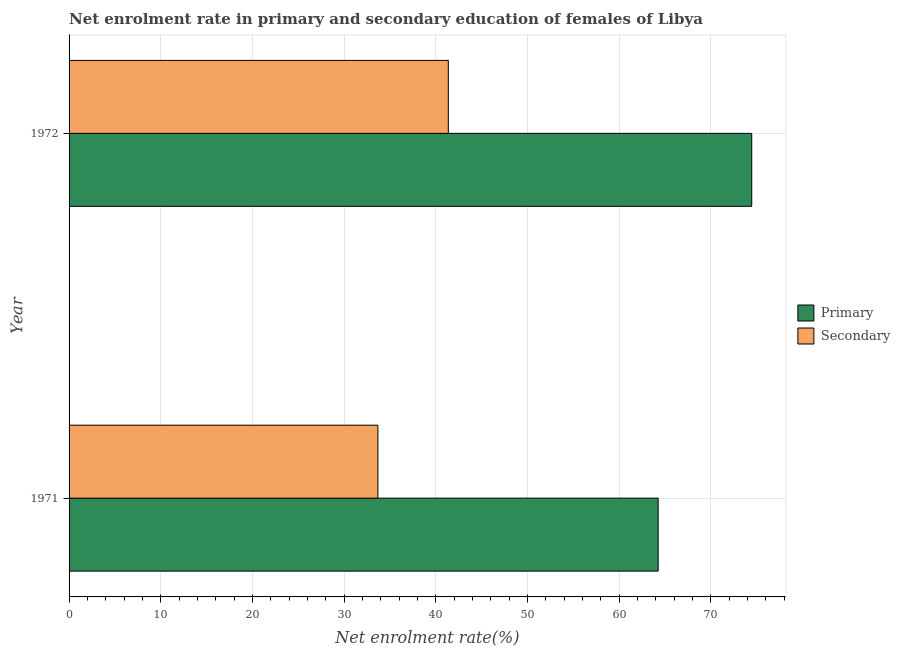How many different coloured bars are there?
Ensure brevity in your answer.  2. How many groups of bars are there?
Make the answer very short. 2. What is the enrollment rate in primary education in 1972?
Make the answer very short. 74.48. Across all years, what is the maximum enrollment rate in primary education?
Offer a terse response. 74.48. Across all years, what is the minimum enrollment rate in primary education?
Offer a very short reply. 64.27. In which year was the enrollment rate in primary education minimum?
Give a very brief answer. 1971. What is the total enrollment rate in secondary education in the graph?
Provide a succinct answer. 75.07. What is the difference between the enrollment rate in secondary education in 1971 and that in 1972?
Offer a terse response. -7.68. What is the difference between the enrollment rate in secondary education in 1971 and the enrollment rate in primary education in 1972?
Provide a short and direct response. -40.79. What is the average enrollment rate in secondary education per year?
Ensure brevity in your answer.  37.53. In the year 1971, what is the difference between the enrollment rate in secondary education and enrollment rate in primary education?
Your answer should be very brief. -30.58. What is the ratio of the enrollment rate in primary education in 1971 to that in 1972?
Provide a succinct answer. 0.86. Is the enrollment rate in primary education in 1971 less than that in 1972?
Your answer should be compact. Yes. In how many years, is the enrollment rate in primary education greater than the average enrollment rate in primary education taken over all years?
Provide a succinct answer. 1. What does the 2nd bar from the top in 1972 represents?
Make the answer very short. Primary. What does the 1st bar from the bottom in 1971 represents?
Keep it short and to the point. Primary. How many bars are there?
Offer a very short reply. 4. Are all the bars in the graph horizontal?
Provide a succinct answer. Yes. How many years are there in the graph?
Keep it short and to the point. 2. Are the values on the major ticks of X-axis written in scientific E-notation?
Ensure brevity in your answer.  No. How are the legend labels stacked?
Your answer should be compact. Vertical. What is the title of the graph?
Your response must be concise. Net enrolment rate in primary and secondary education of females of Libya. What is the label or title of the X-axis?
Provide a short and direct response. Net enrolment rate(%). What is the Net enrolment rate(%) in Primary in 1971?
Provide a short and direct response. 64.27. What is the Net enrolment rate(%) in Secondary in 1971?
Offer a terse response. 33.69. What is the Net enrolment rate(%) in Primary in 1972?
Offer a very short reply. 74.48. What is the Net enrolment rate(%) of Secondary in 1972?
Ensure brevity in your answer.  41.38. Across all years, what is the maximum Net enrolment rate(%) in Primary?
Provide a short and direct response. 74.48. Across all years, what is the maximum Net enrolment rate(%) in Secondary?
Provide a short and direct response. 41.38. Across all years, what is the minimum Net enrolment rate(%) in Primary?
Offer a very short reply. 64.27. Across all years, what is the minimum Net enrolment rate(%) of Secondary?
Your answer should be very brief. 33.69. What is the total Net enrolment rate(%) in Primary in the graph?
Provide a succinct answer. 138.75. What is the total Net enrolment rate(%) in Secondary in the graph?
Make the answer very short. 75.07. What is the difference between the Net enrolment rate(%) of Primary in 1971 and that in 1972?
Ensure brevity in your answer.  -10.21. What is the difference between the Net enrolment rate(%) of Secondary in 1971 and that in 1972?
Provide a short and direct response. -7.68. What is the difference between the Net enrolment rate(%) in Primary in 1971 and the Net enrolment rate(%) in Secondary in 1972?
Your response must be concise. 22.89. What is the average Net enrolment rate(%) of Primary per year?
Give a very brief answer. 69.38. What is the average Net enrolment rate(%) of Secondary per year?
Your answer should be very brief. 37.54. In the year 1971, what is the difference between the Net enrolment rate(%) in Primary and Net enrolment rate(%) in Secondary?
Provide a short and direct response. 30.58. In the year 1972, what is the difference between the Net enrolment rate(%) of Primary and Net enrolment rate(%) of Secondary?
Offer a terse response. 33.1. What is the ratio of the Net enrolment rate(%) of Primary in 1971 to that in 1972?
Ensure brevity in your answer.  0.86. What is the ratio of the Net enrolment rate(%) of Secondary in 1971 to that in 1972?
Ensure brevity in your answer.  0.81. What is the difference between the highest and the second highest Net enrolment rate(%) in Primary?
Offer a very short reply. 10.21. What is the difference between the highest and the second highest Net enrolment rate(%) in Secondary?
Your answer should be compact. 7.68. What is the difference between the highest and the lowest Net enrolment rate(%) of Primary?
Your answer should be very brief. 10.21. What is the difference between the highest and the lowest Net enrolment rate(%) in Secondary?
Keep it short and to the point. 7.68. 